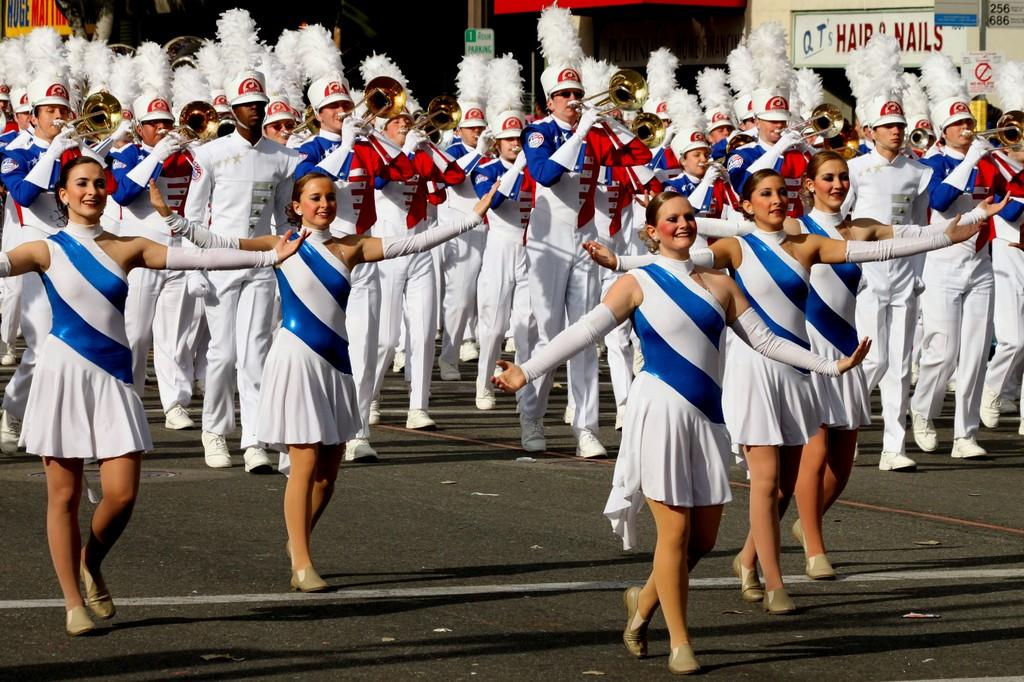<image>
Offer a succinct explanation of the picture presented. A marching band is parading in front of QT's Hair and Nails. 